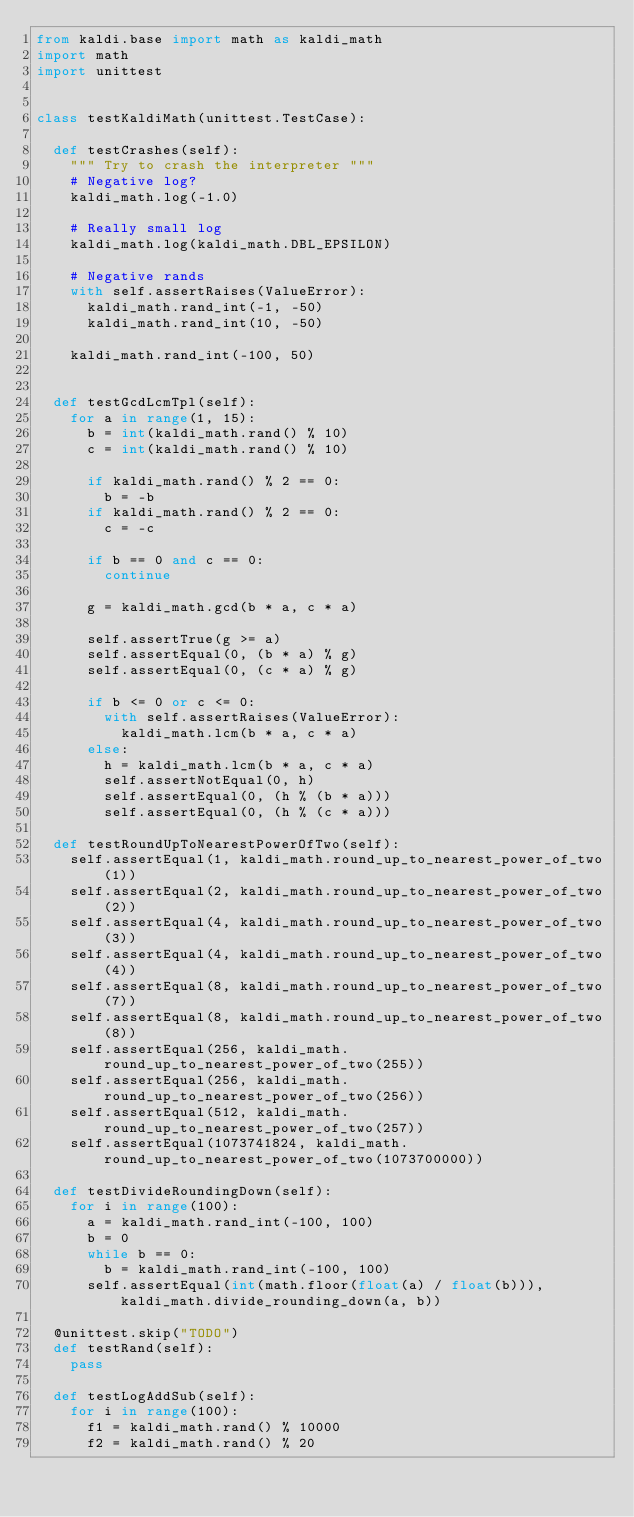<code> <loc_0><loc_0><loc_500><loc_500><_Python_>from kaldi.base import math as kaldi_math
import math
import unittest


class testKaldiMath(unittest.TestCase):

	def testCrashes(self):
		""" Try to crash the interpreter """
		# Negative log?
		kaldi_math.log(-1.0)

		# Really small log
		kaldi_math.log(kaldi_math.DBL_EPSILON)

		# Negative rands
		with self.assertRaises(ValueError):
			kaldi_math.rand_int(-1, -50)
			kaldi_math.rand_int(10, -50)
		
		kaldi_math.rand_int(-100, 50)


	def testGcdLcmTpl(self):
		for a in range(1, 15):
			b = int(kaldi_math.rand() % 10)
			c = int(kaldi_math.rand() % 10)

			if kaldi_math.rand() % 2 == 0:
				b = -b
			if kaldi_math.rand() % 2 == 0:
				c = -c 

			if b == 0 and c == 0:
				continue 

			g = kaldi_math.gcd(b * a, c * a)

			self.assertTrue(g >= a)
			self.assertEqual(0, (b * a) % g)
			self.assertEqual(0, (c * a) % g)

			if b <= 0 or c <= 0:
				with self.assertRaises(ValueError):
					kaldi_math.lcm(b * a, c * a)
			else:
				h = kaldi_math.lcm(b * a, c * a)
				self.assertNotEqual(0, h)
				self.assertEqual(0, (h % (b * a)))
				self.assertEqual(0, (h % (c * a)))

	def testRoundUpToNearestPowerOfTwo(self):
		self.assertEqual(1, kaldi_math.round_up_to_nearest_power_of_two(1))
		self.assertEqual(2, kaldi_math.round_up_to_nearest_power_of_two(2))
		self.assertEqual(4, kaldi_math.round_up_to_nearest_power_of_two(3))
		self.assertEqual(4, kaldi_math.round_up_to_nearest_power_of_two(4))
		self.assertEqual(8, kaldi_math.round_up_to_nearest_power_of_two(7))
		self.assertEqual(8, kaldi_math.round_up_to_nearest_power_of_two(8))
		self.assertEqual(256, kaldi_math.round_up_to_nearest_power_of_two(255))
		self.assertEqual(256, kaldi_math.round_up_to_nearest_power_of_two(256))
		self.assertEqual(512, kaldi_math.round_up_to_nearest_power_of_two(257))
		self.assertEqual(1073741824, kaldi_math.round_up_to_nearest_power_of_two(1073700000))

	def testDivideRoundingDown(self):
		for i in range(100):
			a = kaldi_math.rand_int(-100, 100)
			b = 0
			while b == 0:
				b = kaldi_math.rand_int(-100, 100)
			self.assertEqual(int(math.floor(float(a) / float(b))), kaldi_math.divide_rounding_down(a, b))

	@unittest.skip("TODO")
	def testRand(self):
		pass		

	def testLogAddSub(self):
		for i in range(100):
			f1 = kaldi_math.rand() % 10000
			f2 = kaldi_math.rand() % 20</code> 